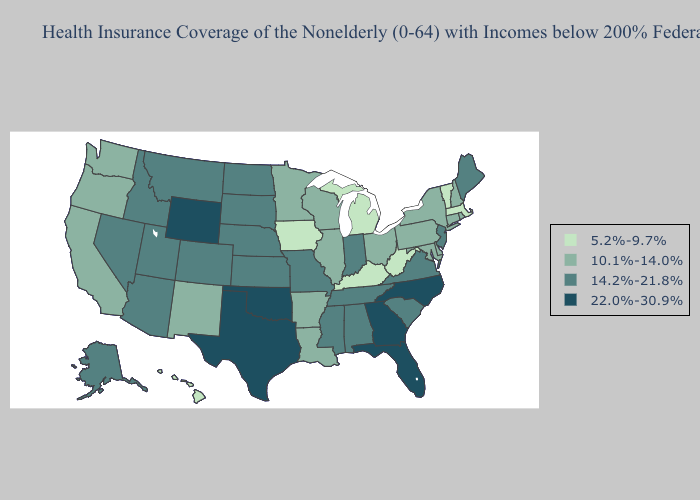Name the states that have a value in the range 22.0%-30.9%?
Be succinct. Florida, Georgia, North Carolina, Oklahoma, Texas, Wyoming. What is the highest value in states that border Arkansas?
Answer briefly. 22.0%-30.9%. What is the lowest value in states that border New Mexico?
Short answer required. 14.2%-21.8%. Name the states that have a value in the range 22.0%-30.9%?
Write a very short answer. Florida, Georgia, North Carolina, Oklahoma, Texas, Wyoming. Name the states that have a value in the range 5.2%-9.7%?
Be succinct. Hawaii, Iowa, Kentucky, Massachusetts, Michigan, Vermont, West Virginia. What is the lowest value in states that border Montana?
Give a very brief answer. 14.2%-21.8%. Which states have the lowest value in the West?
Be succinct. Hawaii. What is the lowest value in states that border Washington?
Quick response, please. 10.1%-14.0%. Which states have the lowest value in the South?
Keep it brief. Kentucky, West Virginia. Does Maine have the highest value in the Northeast?
Quick response, please. Yes. What is the value of Wisconsin?
Keep it brief. 10.1%-14.0%. Name the states that have a value in the range 10.1%-14.0%?
Be succinct. Arkansas, California, Connecticut, Delaware, Illinois, Louisiana, Maryland, Minnesota, New Hampshire, New Mexico, New York, Ohio, Oregon, Pennsylvania, Rhode Island, Washington, Wisconsin. What is the value of Nevada?
Keep it brief. 14.2%-21.8%. What is the value of Michigan?
Answer briefly. 5.2%-9.7%. Does the first symbol in the legend represent the smallest category?
Concise answer only. Yes. 